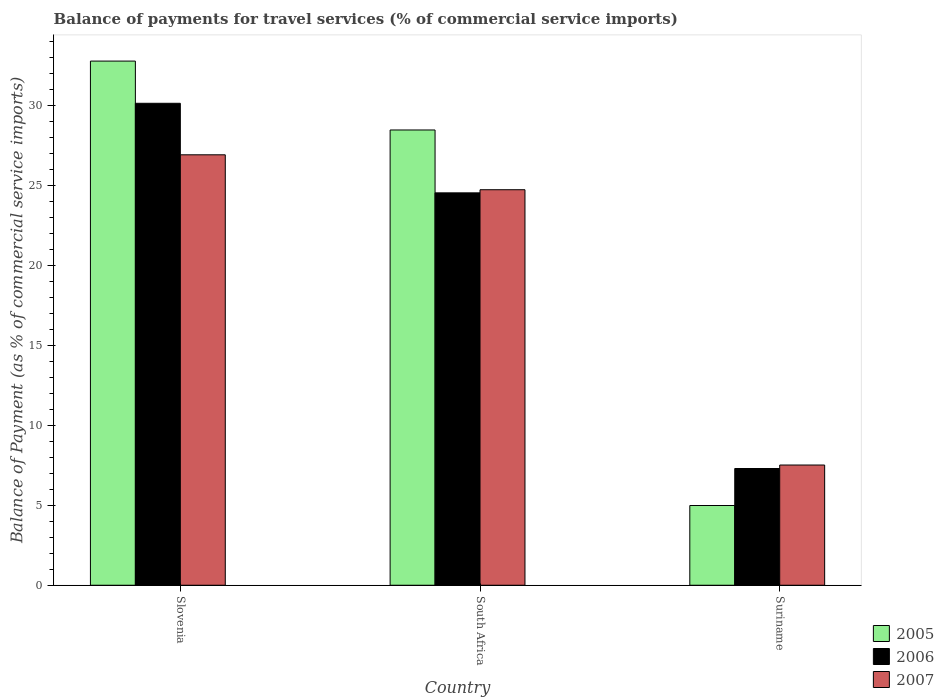What is the label of the 3rd group of bars from the left?
Give a very brief answer. Suriname. What is the balance of payments for travel services in 2005 in South Africa?
Make the answer very short. 28.45. Across all countries, what is the maximum balance of payments for travel services in 2007?
Offer a terse response. 26.9. Across all countries, what is the minimum balance of payments for travel services in 2005?
Your answer should be very brief. 4.98. In which country was the balance of payments for travel services in 2006 maximum?
Offer a terse response. Slovenia. In which country was the balance of payments for travel services in 2005 minimum?
Your answer should be compact. Suriname. What is the total balance of payments for travel services in 2005 in the graph?
Ensure brevity in your answer.  66.18. What is the difference between the balance of payments for travel services in 2007 in Slovenia and that in South Africa?
Give a very brief answer. 2.18. What is the difference between the balance of payments for travel services in 2006 in Suriname and the balance of payments for travel services in 2005 in Slovenia?
Provide a succinct answer. -25.46. What is the average balance of payments for travel services in 2007 per country?
Your response must be concise. 19.71. What is the difference between the balance of payments for travel services of/in 2006 and balance of payments for travel services of/in 2007 in Slovenia?
Make the answer very short. 3.22. What is the ratio of the balance of payments for travel services in 2007 in Slovenia to that in Suriname?
Provide a short and direct response. 3.58. Is the difference between the balance of payments for travel services in 2006 in Slovenia and Suriname greater than the difference between the balance of payments for travel services in 2007 in Slovenia and Suriname?
Your answer should be very brief. Yes. What is the difference between the highest and the second highest balance of payments for travel services in 2007?
Provide a short and direct response. -2.18. What is the difference between the highest and the lowest balance of payments for travel services in 2005?
Provide a succinct answer. 27.77. In how many countries, is the balance of payments for travel services in 2006 greater than the average balance of payments for travel services in 2006 taken over all countries?
Offer a terse response. 2. Is the sum of the balance of payments for travel services in 2006 in Slovenia and Suriname greater than the maximum balance of payments for travel services in 2005 across all countries?
Your answer should be compact. Yes. What does the 1st bar from the right in Slovenia represents?
Make the answer very short. 2007. Is it the case that in every country, the sum of the balance of payments for travel services in 2005 and balance of payments for travel services in 2006 is greater than the balance of payments for travel services in 2007?
Offer a terse response. Yes. Are all the bars in the graph horizontal?
Provide a succinct answer. No. Does the graph contain grids?
Your answer should be very brief. No. Where does the legend appear in the graph?
Your response must be concise. Bottom right. What is the title of the graph?
Keep it short and to the point. Balance of payments for travel services (% of commercial service imports). What is the label or title of the Y-axis?
Your answer should be very brief. Balance of Payment (as % of commercial service imports). What is the Balance of Payment (as % of commercial service imports) in 2005 in Slovenia?
Provide a short and direct response. 32.75. What is the Balance of Payment (as % of commercial service imports) of 2006 in Slovenia?
Offer a terse response. 30.11. What is the Balance of Payment (as % of commercial service imports) in 2007 in Slovenia?
Your answer should be compact. 26.9. What is the Balance of Payment (as % of commercial service imports) of 2005 in South Africa?
Offer a terse response. 28.45. What is the Balance of Payment (as % of commercial service imports) in 2006 in South Africa?
Keep it short and to the point. 24.52. What is the Balance of Payment (as % of commercial service imports) of 2007 in South Africa?
Provide a succinct answer. 24.71. What is the Balance of Payment (as % of commercial service imports) of 2005 in Suriname?
Ensure brevity in your answer.  4.98. What is the Balance of Payment (as % of commercial service imports) in 2006 in Suriname?
Give a very brief answer. 7.29. What is the Balance of Payment (as % of commercial service imports) in 2007 in Suriname?
Make the answer very short. 7.51. Across all countries, what is the maximum Balance of Payment (as % of commercial service imports) in 2005?
Give a very brief answer. 32.75. Across all countries, what is the maximum Balance of Payment (as % of commercial service imports) of 2006?
Offer a terse response. 30.11. Across all countries, what is the maximum Balance of Payment (as % of commercial service imports) of 2007?
Give a very brief answer. 26.9. Across all countries, what is the minimum Balance of Payment (as % of commercial service imports) of 2005?
Give a very brief answer. 4.98. Across all countries, what is the minimum Balance of Payment (as % of commercial service imports) of 2006?
Your answer should be very brief. 7.29. Across all countries, what is the minimum Balance of Payment (as % of commercial service imports) in 2007?
Your answer should be very brief. 7.51. What is the total Balance of Payment (as % of commercial service imports) of 2005 in the graph?
Your answer should be very brief. 66.18. What is the total Balance of Payment (as % of commercial service imports) of 2006 in the graph?
Your response must be concise. 61.93. What is the total Balance of Payment (as % of commercial service imports) in 2007 in the graph?
Keep it short and to the point. 59.12. What is the difference between the Balance of Payment (as % of commercial service imports) in 2005 in Slovenia and that in South Africa?
Provide a succinct answer. 4.3. What is the difference between the Balance of Payment (as % of commercial service imports) of 2006 in Slovenia and that in South Africa?
Offer a terse response. 5.6. What is the difference between the Balance of Payment (as % of commercial service imports) of 2007 in Slovenia and that in South Africa?
Your answer should be compact. 2.18. What is the difference between the Balance of Payment (as % of commercial service imports) of 2005 in Slovenia and that in Suriname?
Your answer should be compact. 27.77. What is the difference between the Balance of Payment (as % of commercial service imports) of 2006 in Slovenia and that in Suriname?
Offer a terse response. 22.82. What is the difference between the Balance of Payment (as % of commercial service imports) of 2007 in Slovenia and that in Suriname?
Your answer should be compact. 19.38. What is the difference between the Balance of Payment (as % of commercial service imports) in 2005 in South Africa and that in Suriname?
Offer a very short reply. 23.46. What is the difference between the Balance of Payment (as % of commercial service imports) in 2006 in South Africa and that in Suriname?
Your answer should be compact. 17.22. What is the difference between the Balance of Payment (as % of commercial service imports) of 2007 in South Africa and that in Suriname?
Give a very brief answer. 17.2. What is the difference between the Balance of Payment (as % of commercial service imports) of 2005 in Slovenia and the Balance of Payment (as % of commercial service imports) of 2006 in South Africa?
Provide a succinct answer. 8.23. What is the difference between the Balance of Payment (as % of commercial service imports) in 2005 in Slovenia and the Balance of Payment (as % of commercial service imports) in 2007 in South Africa?
Provide a short and direct response. 8.04. What is the difference between the Balance of Payment (as % of commercial service imports) of 2006 in Slovenia and the Balance of Payment (as % of commercial service imports) of 2007 in South Africa?
Provide a short and direct response. 5.4. What is the difference between the Balance of Payment (as % of commercial service imports) of 2005 in Slovenia and the Balance of Payment (as % of commercial service imports) of 2006 in Suriname?
Your answer should be compact. 25.46. What is the difference between the Balance of Payment (as % of commercial service imports) in 2005 in Slovenia and the Balance of Payment (as % of commercial service imports) in 2007 in Suriname?
Make the answer very short. 25.24. What is the difference between the Balance of Payment (as % of commercial service imports) of 2006 in Slovenia and the Balance of Payment (as % of commercial service imports) of 2007 in Suriname?
Provide a succinct answer. 22.6. What is the difference between the Balance of Payment (as % of commercial service imports) in 2005 in South Africa and the Balance of Payment (as % of commercial service imports) in 2006 in Suriname?
Your answer should be compact. 21.15. What is the difference between the Balance of Payment (as % of commercial service imports) of 2005 in South Africa and the Balance of Payment (as % of commercial service imports) of 2007 in Suriname?
Provide a short and direct response. 20.94. What is the difference between the Balance of Payment (as % of commercial service imports) in 2006 in South Africa and the Balance of Payment (as % of commercial service imports) in 2007 in Suriname?
Your answer should be very brief. 17.01. What is the average Balance of Payment (as % of commercial service imports) in 2005 per country?
Offer a terse response. 22.06. What is the average Balance of Payment (as % of commercial service imports) of 2006 per country?
Make the answer very short. 20.64. What is the average Balance of Payment (as % of commercial service imports) in 2007 per country?
Give a very brief answer. 19.71. What is the difference between the Balance of Payment (as % of commercial service imports) of 2005 and Balance of Payment (as % of commercial service imports) of 2006 in Slovenia?
Provide a short and direct response. 2.64. What is the difference between the Balance of Payment (as % of commercial service imports) of 2005 and Balance of Payment (as % of commercial service imports) of 2007 in Slovenia?
Ensure brevity in your answer.  5.86. What is the difference between the Balance of Payment (as % of commercial service imports) of 2006 and Balance of Payment (as % of commercial service imports) of 2007 in Slovenia?
Your answer should be compact. 3.22. What is the difference between the Balance of Payment (as % of commercial service imports) in 2005 and Balance of Payment (as % of commercial service imports) in 2006 in South Africa?
Keep it short and to the point. 3.93. What is the difference between the Balance of Payment (as % of commercial service imports) in 2005 and Balance of Payment (as % of commercial service imports) in 2007 in South Africa?
Provide a short and direct response. 3.73. What is the difference between the Balance of Payment (as % of commercial service imports) in 2006 and Balance of Payment (as % of commercial service imports) in 2007 in South Africa?
Offer a very short reply. -0.2. What is the difference between the Balance of Payment (as % of commercial service imports) in 2005 and Balance of Payment (as % of commercial service imports) in 2006 in Suriname?
Your answer should be compact. -2.31. What is the difference between the Balance of Payment (as % of commercial service imports) of 2005 and Balance of Payment (as % of commercial service imports) of 2007 in Suriname?
Provide a short and direct response. -2.53. What is the difference between the Balance of Payment (as % of commercial service imports) of 2006 and Balance of Payment (as % of commercial service imports) of 2007 in Suriname?
Offer a terse response. -0.22. What is the ratio of the Balance of Payment (as % of commercial service imports) of 2005 in Slovenia to that in South Africa?
Provide a succinct answer. 1.15. What is the ratio of the Balance of Payment (as % of commercial service imports) of 2006 in Slovenia to that in South Africa?
Ensure brevity in your answer.  1.23. What is the ratio of the Balance of Payment (as % of commercial service imports) of 2007 in Slovenia to that in South Africa?
Give a very brief answer. 1.09. What is the ratio of the Balance of Payment (as % of commercial service imports) of 2005 in Slovenia to that in Suriname?
Make the answer very short. 6.57. What is the ratio of the Balance of Payment (as % of commercial service imports) of 2006 in Slovenia to that in Suriname?
Offer a terse response. 4.13. What is the ratio of the Balance of Payment (as % of commercial service imports) in 2007 in Slovenia to that in Suriname?
Provide a succinct answer. 3.58. What is the ratio of the Balance of Payment (as % of commercial service imports) in 2005 in South Africa to that in Suriname?
Offer a very short reply. 5.71. What is the ratio of the Balance of Payment (as % of commercial service imports) of 2006 in South Africa to that in Suriname?
Your answer should be compact. 3.36. What is the ratio of the Balance of Payment (as % of commercial service imports) of 2007 in South Africa to that in Suriname?
Keep it short and to the point. 3.29. What is the difference between the highest and the second highest Balance of Payment (as % of commercial service imports) of 2005?
Make the answer very short. 4.3. What is the difference between the highest and the second highest Balance of Payment (as % of commercial service imports) in 2006?
Offer a terse response. 5.6. What is the difference between the highest and the second highest Balance of Payment (as % of commercial service imports) of 2007?
Keep it short and to the point. 2.18. What is the difference between the highest and the lowest Balance of Payment (as % of commercial service imports) in 2005?
Provide a succinct answer. 27.77. What is the difference between the highest and the lowest Balance of Payment (as % of commercial service imports) of 2006?
Your answer should be compact. 22.82. What is the difference between the highest and the lowest Balance of Payment (as % of commercial service imports) of 2007?
Provide a short and direct response. 19.38. 